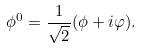Convert formula to latex. <formula><loc_0><loc_0><loc_500><loc_500>\phi ^ { 0 } = \frac { 1 } { \sqrt { 2 } } ( \phi + i \varphi ) .</formula> 